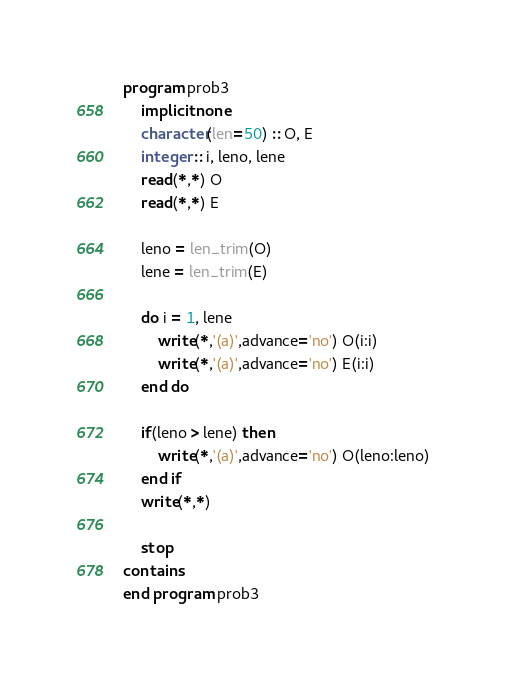<code> <loc_0><loc_0><loc_500><loc_500><_FORTRAN_>program prob3
    implicit none
    character(len=50) :: O, E
    integer :: i, leno, lene
    read(*,*) O
    read(*,*) E

    leno = len_trim(O)
    lene = len_trim(E)

    do i = 1, lene
        write(*,'(a)',advance='no') O(i:i)
        write(*,'(a)',advance='no') E(i:i)
    end do

    if(leno > lene) then
        write(*,'(a)',advance='no') O(leno:leno)
    end if
    write(*,*)

    stop
contains
end program prob3</code> 